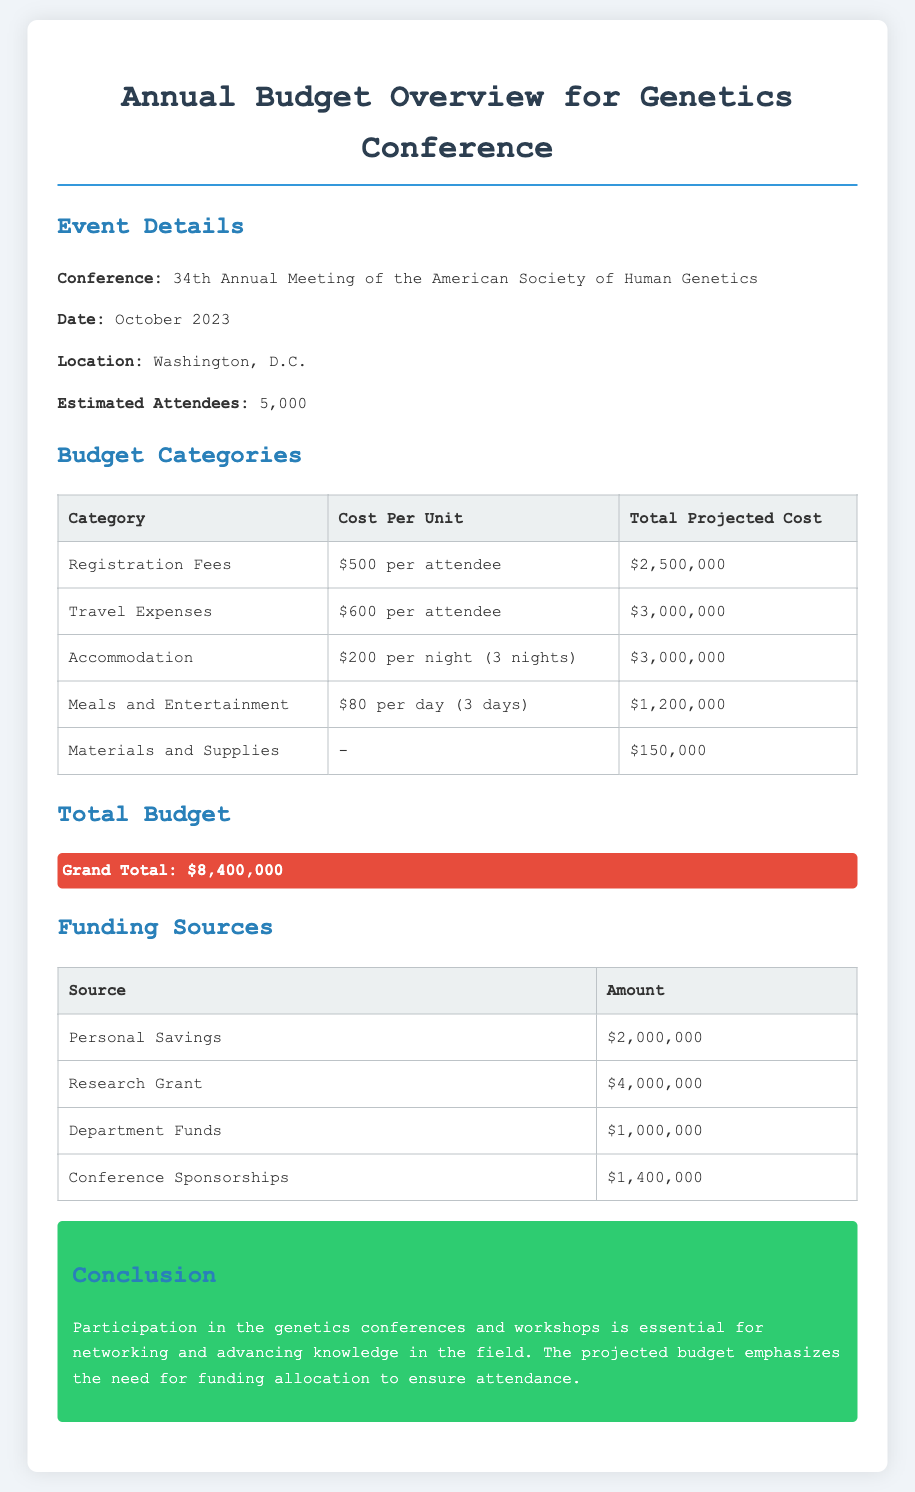what is the conference name? The conference name is stated in the document under Event Details as the 34th Annual Meeting of the American Society of Human Genetics.
Answer: 34th Annual Meeting of the American Society of Human Genetics what is the total projected cost for registration fees? The total projected cost for registration fees is found in the Budget Categories table under Total Projected Cost for Registration Fees.
Answer: $2,500,000 how many attendees are estimated for the conference? The estimated attendees are listed in the Event Details section of the document.
Answer: 5,000 what is the grand total budget? The grand total budget is highlighted in the Total Budget section of the document.
Answer: $8,400,000 which funding source provides the largest amount? The largest funding source is identified in the Funding Sources table, comparing all amounts provided.
Answer: Research Grant how much is allocated for meals and entertainment? The allocation for meals and entertainment is detailed in the Budget Categories table under Total Projected Cost for Meals and Entertainment.
Answer: $1,200,000 how many nights of accommodation are planned for attendees? The number of nights for accommodation is mentioned in the Budget Categories section under Accommodation.
Answer: 3 nights what is the primary purpose of participation in genetics conferences? The primary purpose of participation is stated in the Conclusion section of the document, summarizing its significance.
Answer: Networking and advancing knowledge what is the funding amount from Department Funds? The amount from Department Funds can be found in the Funding Sources table under Amount for that specific source.
Answer: $1,000,000 